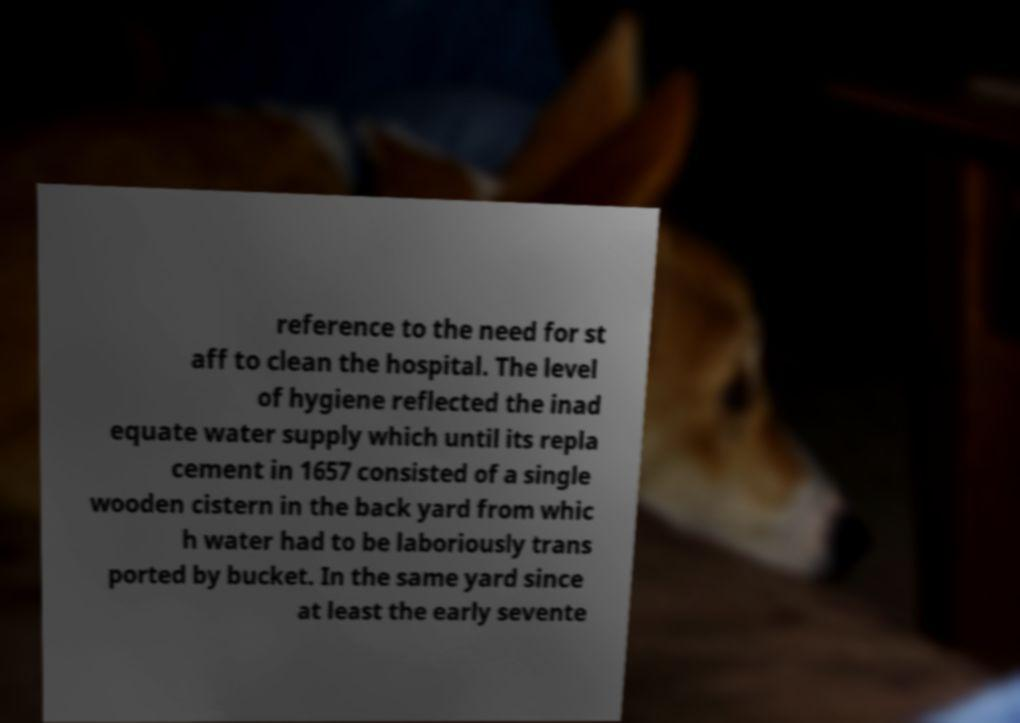Please read and relay the text visible in this image. What does it say? reference to the need for st aff to clean the hospital. The level of hygiene reflected the inad equate water supply which until its repla cement in 1657 consisted of a single wooden cistern in the back yard from whic h water had to be laboriously trans ported by bucket. In the same yard since at least the early sevente 